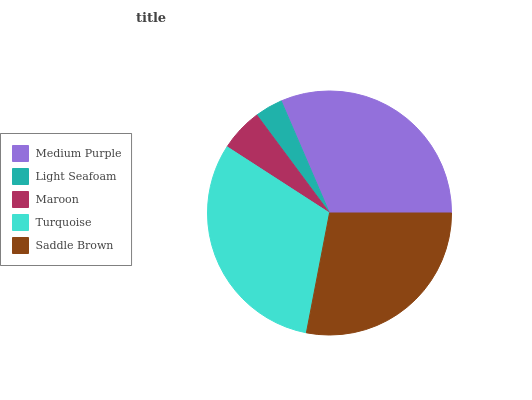Is Light Seafoam the minimum?
Answer yes or no. Yes. Is Medium Purple the maximum?
Answer yes or no. Yes. Is Maroon the minimum?
Answer yes or no. No. Is Maroon the maximum?
Answer yes or no. No. Is Maroon greater than Light Seafoam?
Answer yes or no. Yes. Is Light Seafoam less than Maroon?
Answer yes or no. Yes. Is Light Seafoam greater than Maroon?
Answer yes or no. No. Is Maroon less than Light Seafoam?
Answer yes or no. No. Is Saddle Brown the high median?
Answer yes or no. Yes. Is Saddle Brown the low median?
Answer yes or no. Yes. Is Medium Purple the high median?
Answer yes or no. No. Is Maroon the low median?
Answer yes or no. No. 